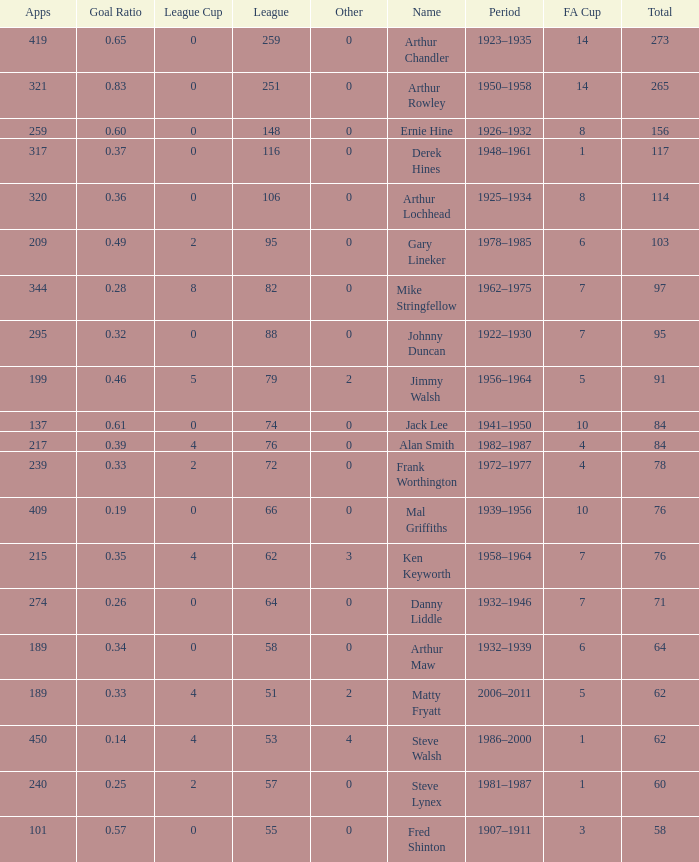What's the highest FA Cup with the Name of Alan Smith, and League Cup smaller than 4? None. 